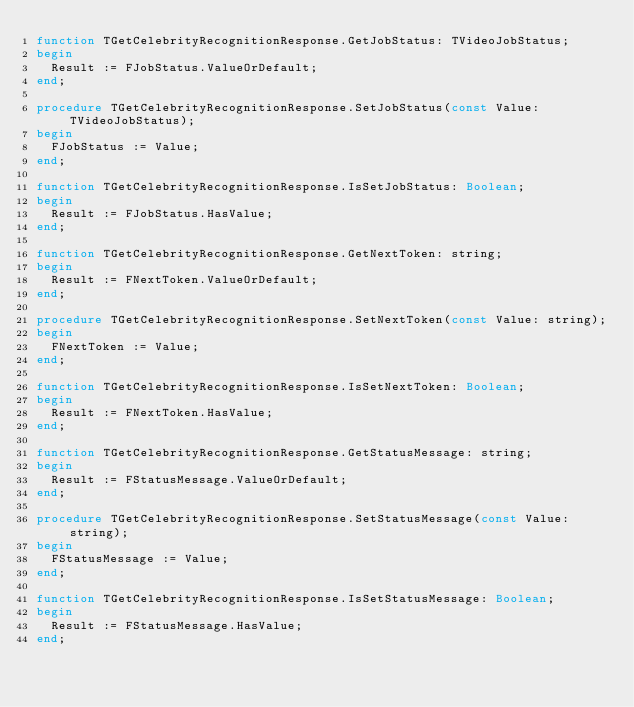Convert code to text. <code><loc_0><loc_0><loc_500><loc_500><_Pascal_>function TGetCelebrityRecognitionResponse.GetJobStatus: TVideoJobStatus;
begin
  Result := FJobStatus.ValueOrDefault;
end;

procedure TGetCelebrityRecognitionResponse.SetJobStatus(const Value: TVideoJobStatus);
begin
  FJobStatus := Value;
end;

function TGetCelebrityRecognitionResponse.IsSetJobStatus: Boolean;
begin
  Result := FJobStatus.HasValue;
end;

function TGetCelebrityRecognitionResponse.GetNextToken: string;
begin
  Result := FNextToken.ValueOrDefault;
end;

procedure TGetCelebrityRecognitionResponse.SetNextToken(const Value: string);
begin
  FNextToken := Value;
end;

function TGetCelebrityRecognitionResponse.IsSetNextToken: Boolean;
begin
  Result := FNextToken.HasValue;
end;

function TGetCelebrityRecognitionResponse.GetStatusMessage: string;
begin
  Result := FStatusMessage.ValueOrDefault;
end;

procedure TGetCelebrityRecognitionResponse.SetStatusMessage(const Value: string);
begin
  FStatusMessage := Value;
end;

function TGetCelebrityRecognitionResponse.IsSetStatusMessage: Boolean;
begin
  Result := FStatusMessage.HasValue;
end;
</code> 